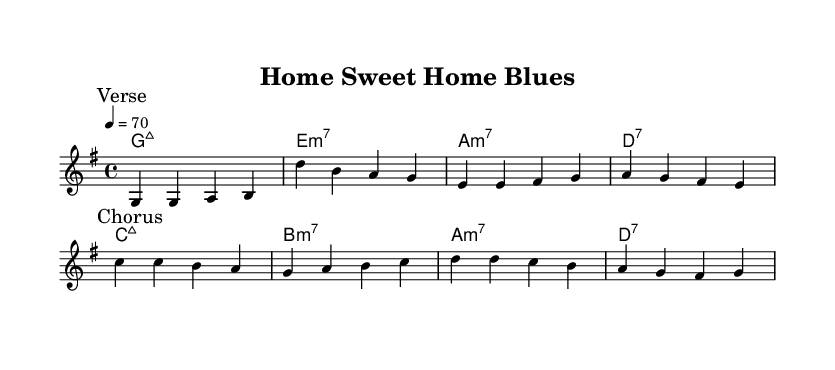What is the key signature of this music? The key signature is G major, which has one sharp (F#).
Answer: G major What is the time signature of the music? The time signature is 4/4, meaning there are four beats in each measure.
Answer: 4/4 What is the tempo marking for this piece? The tempo marking indicates a speed of 70 beats per minute.
Answer: 70 How many verses are present in this section of the music? There is one verse indicated in the score, followed by a chorus.
Answer: One Which chord follows the G major chord in the verse progression? The chord progression in the verse starts with G major and is followed by E minor 7.
Answer: E minor 7 What is the main theme expressed in the lyrics of this song? The main theme expressed in the lyrics incorporates the joys and challenges of homeownership.
Answer: Homeownership What emotion is conveyed through the chorus? The chorus expresses both happiness and a sense of learning through the experience of owning a home.
Answer: Happiness and learning 